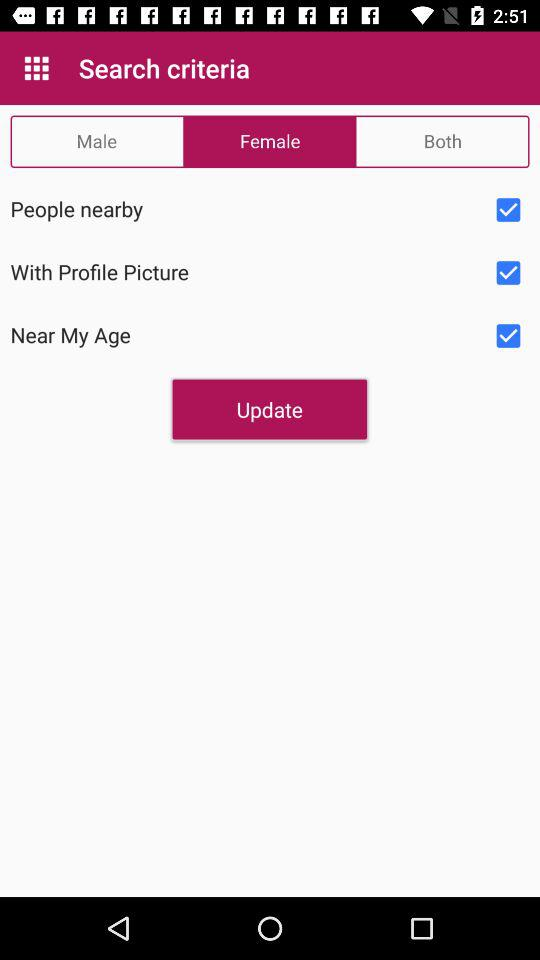What is the status of the "People nearby"? The status is "on". 